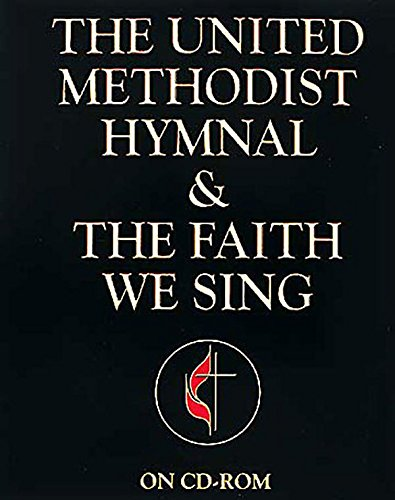In what ways might this hymnal be used outside of traditional services? Beyond typical church services, 'The United Methodist Hymnal' can be used in personal devotion, small group gatherings, or other church-related activities. It can serve as a resource for meditation, prayer, or even musical inspiration for those seeking to deepen their faith. 